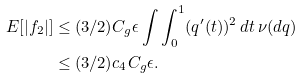Convert formula to latex. <formula><loc_0><loc_0><loc_500><loc_500>E [ | f _ { 2 } | ] & \leq ( 3 / 2 ) C _ { g } \epsilon \int \int _ { 0 } ^ { 1 } ( q ^ { \prime } ( t ) ) ^ { 2 } \, d t \, \nu ( d q ) \\ & \leq ( 3 / 2 ) c _ { 4 } C _ { g } \epsilon .</formula> 